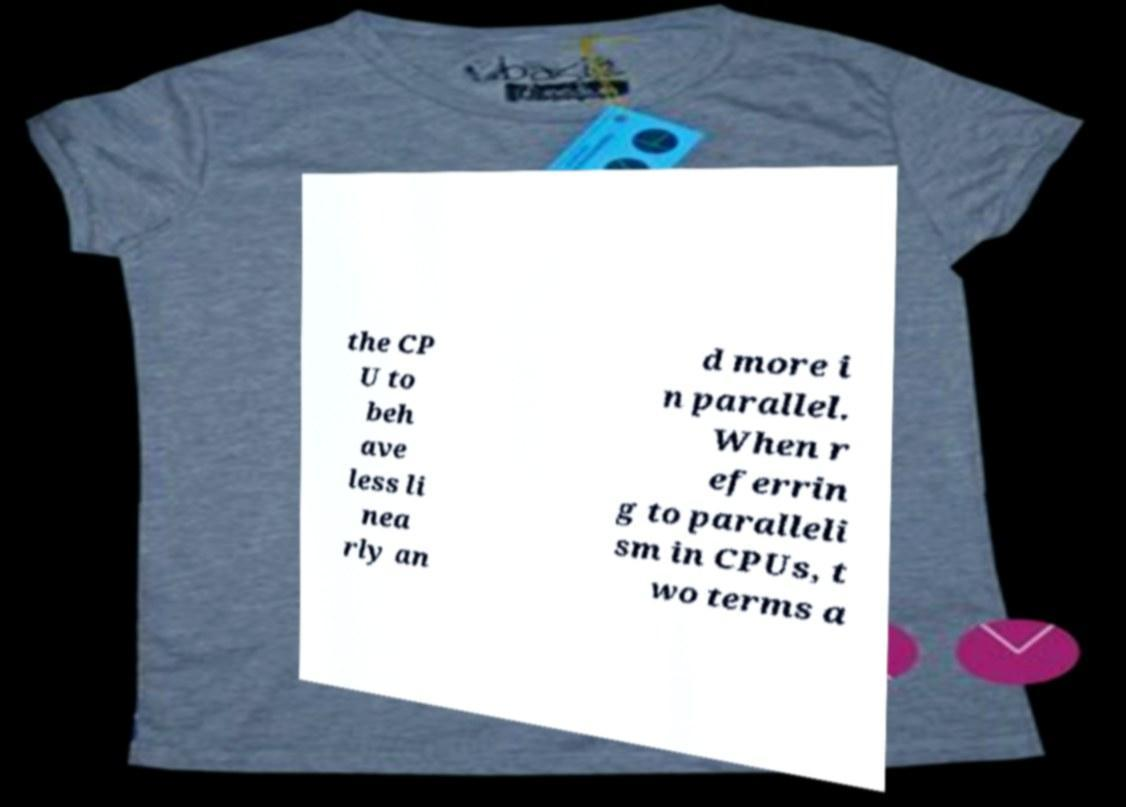For documentation purposes, I need the text within this image transcribed. Could you provide that? the CP U to beh ave less li nea rly an d more i n parallel. When r eferrin g to paralleli sm in CPUs, t wo terms a 